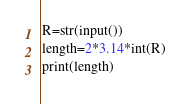<code> <loc_0><loc_0><loc_500><loc_500><_Python_>R=str(input())
length=2*3.14*int(R)
print(length)</code> 